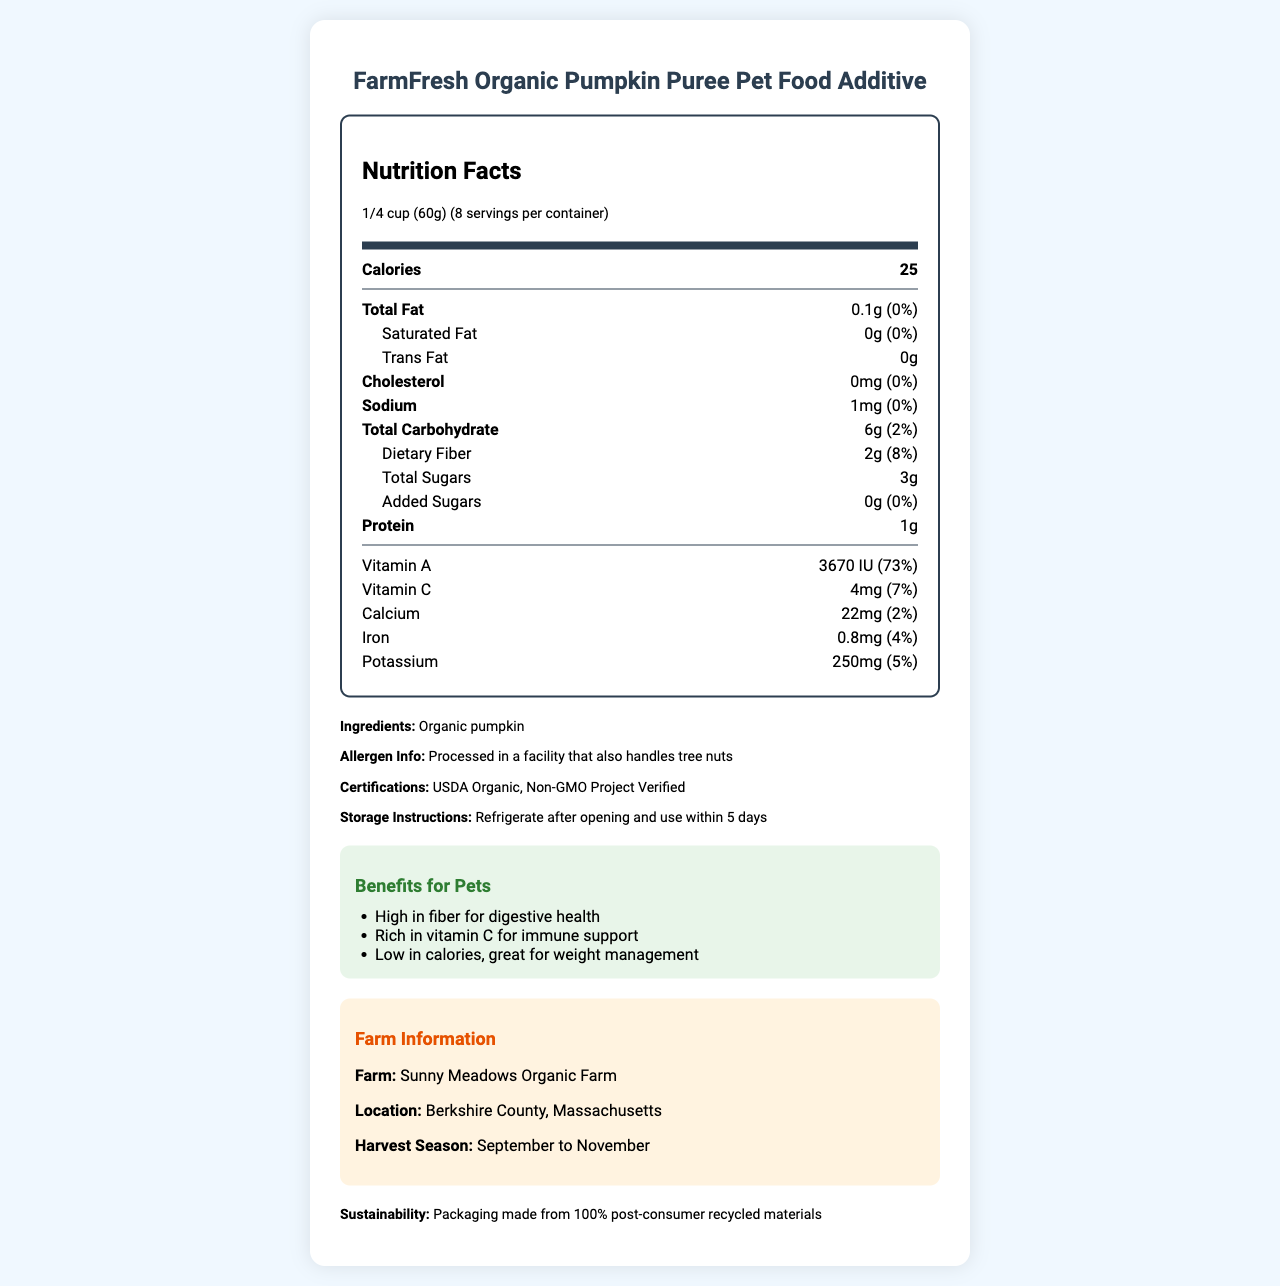what is the serving size of FarmFresh Organic Pumpkin Puree Pet Food Additive? The serving size of the product is directly mentioned under the nutrition header as 1/4 cup (60g).
Answer: 1/4 cup (60g) how many servings does one container have? The number of servings per container is written next to the serving size in the nutrition label, indicating there are 8 servings per container.
Answer: 8 what is the total amount of dietary fiber per serving? The amount of dietary fiber per serving is listed under the Total Carbohydrate section as 2g.
Answer: 2g how much vitamin C does each serving provide? Under the vitamins section, it lists that each serving contains 4mg of Vitamin C.
Answer: 4mg what is the daily value percentage of dietary fiber per serving? The percentage of daily value for dietary fiber per serving is listed as 8% next to the amount of dietary fiber.
Answer: 8% which vitamin has the highest daily value percentage per serving? A. Vitamin A B. Vitamin C C. Calcium D. Iron Vitamin A has the highest daily value percentage at 73%, compared to Vitamin C at 7%, Calcium at 2%, and Iron at 4%.
Answer: A how much sodium is there per serving? A. 1mg B. 5mg C. 10mg D. 20mg Sodium content per serving is directly mentioned as 1mg next to the sodium entry in the nutrition label.
Answer: A is the FarmFresh Organic Pumpkin Puree Pet Food Additive a good source of protein? The product only contains 1g of protein per serving, making it a low source of protein.
Answer: No describe the main health benefits of FarmFresh Organic Pumpkin Puree Pet Food Additive for pets. The benefits section specifies that the product is high in fiber aiding digestion, rich in vitamin C supporting the immune system, and low in calories which helps in weight management.
Answer: High fiber for digestive health, rich in vitamin C for immune support, low in calories for weight management. can you tell me how this product is packaged? The document does not provide enough visual information on the packaging details other than stating that it's made from 100% post-consumer recycled materials.
Answer: Not enough information 